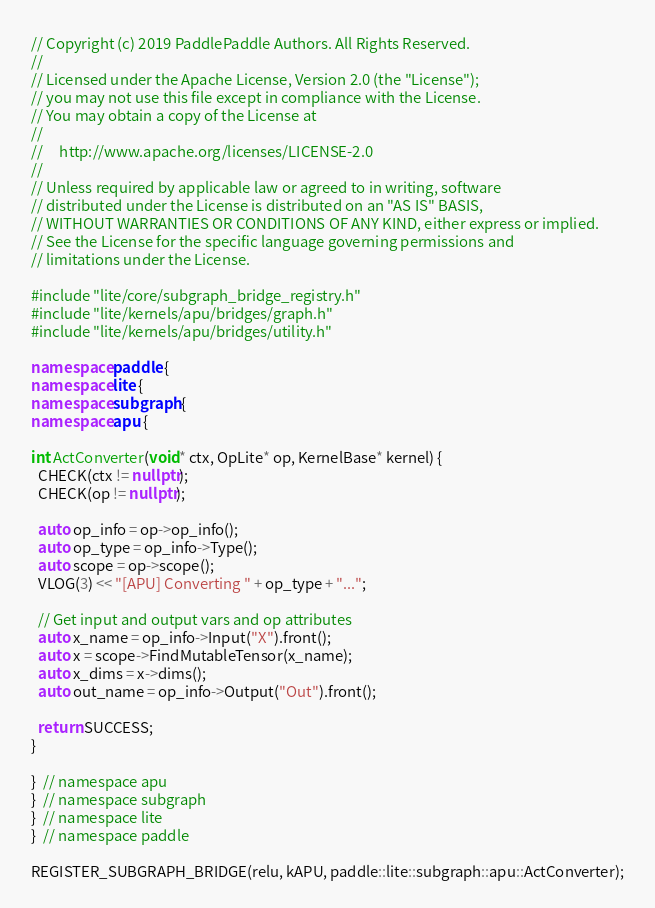<code> <loc_0><loc_0><loc_500><loc_500><_C++_>// Copyright (c) 2019 PaddlePaddle Authors. All Rights Reserved.
//
// Licensed under the Apache License, Version 2.0 (the "License");
// you may not use this file except in compliance with the License.
// You may obtain a copy of the License at
//
//     http://www.apache.org/licenses/LICENSE-2.0
//
// Unless required by applicable law or agreed to in writing, software
// distributed under the License is distributed on an "AS IS" BASIS,
// WITHOUT WARRANTIES OR CONDITIONS OF ANY KIND, either express or implied.
// See the License for the specific language governing permissions and
// limitations under the License.

#include "lite/core/subgraph_bridge_registry.h"
#include "lite/kernels/apu/bridges/graph.h"
#include "lite/kernels/apu/bridges/utility.h"

namespace paddle {
namespace lite {
namespace subgraph {
namespace apu {

int ActConverter(void* ctx, OpLite* op, KernelBase* kernel) {
  CHECK(ctx != nullptr);
  CHECK(op != nullptr);

  auto op_info = op->op_info();
  auto op_type = op_info->Type();
  auto scope = op->scope();
  VLOG(3) << "[APU] Converting " + op_type + "...";

  // Get input and output vars and op attributes
  auto x_name = op_info->Input("X").front();
  auto x = scope->FindMutableTensor(x_name);
  auto x_dims = x->dims();
  auto out_name = op_info->Output("Out").front();

  return SUCCESS;
}

}  // namespace apu
}  // namespace subgraph
}  // namespace lite
}  // namespace paddle

REGISTER_SUBGRAPH_BRIDGE(relu, kAPU, paddle::lite::subgraph::apu::ActConverter);
</code> 